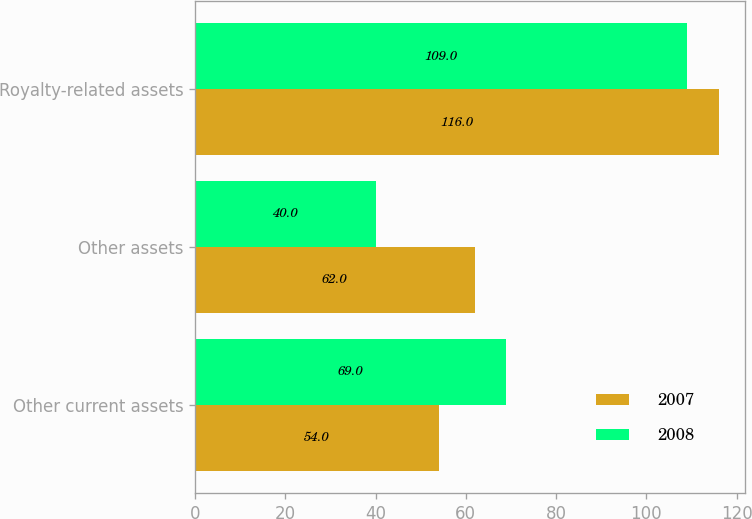<chart> <loc_0><loc_0><loc_500><loc_500><stacked_bar_chart><ecel><fcel>Other current assets<fcel>Other assets<fcel>Royalty-related assets<nl><fcel>2007<fcel>54<fcel>62<fcel>116<nl><fcel>2008<fcel>69<fcel>40<fcel>109<nl></chart> 